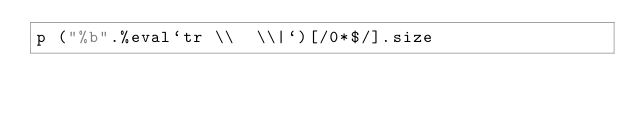Convert code to text. <code><loc_0><loc_0><loc_500><loc_500><_Ruby_>p ("%b".%eval`tr \\  \\|`)[/0*$/].size</code> 